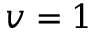Convert formula to latex. <formula><loc_0><loc_0><loc_500><loc_500>v = 1</formula> 